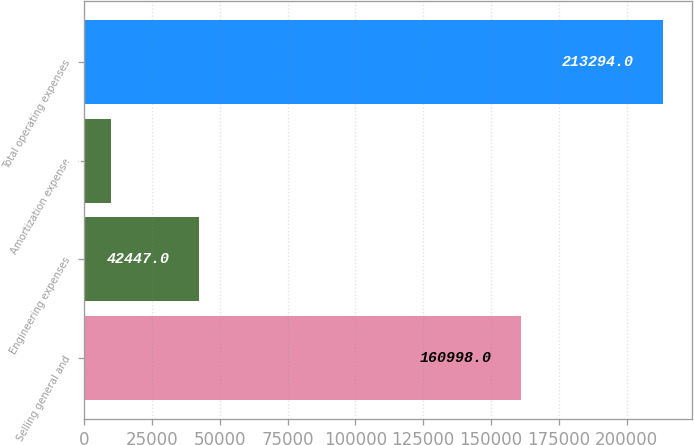<chart> <loc_0><loc_0><loc_500><loc_500><bar_chart><fcel>Selling general and<fcel>Engineering expenses<fcel>Amortization expense<fcel>Total operating expenses<nl><fcel>160998<fcel>42447<fcel>9849<fcel>213294<nl></chart> 